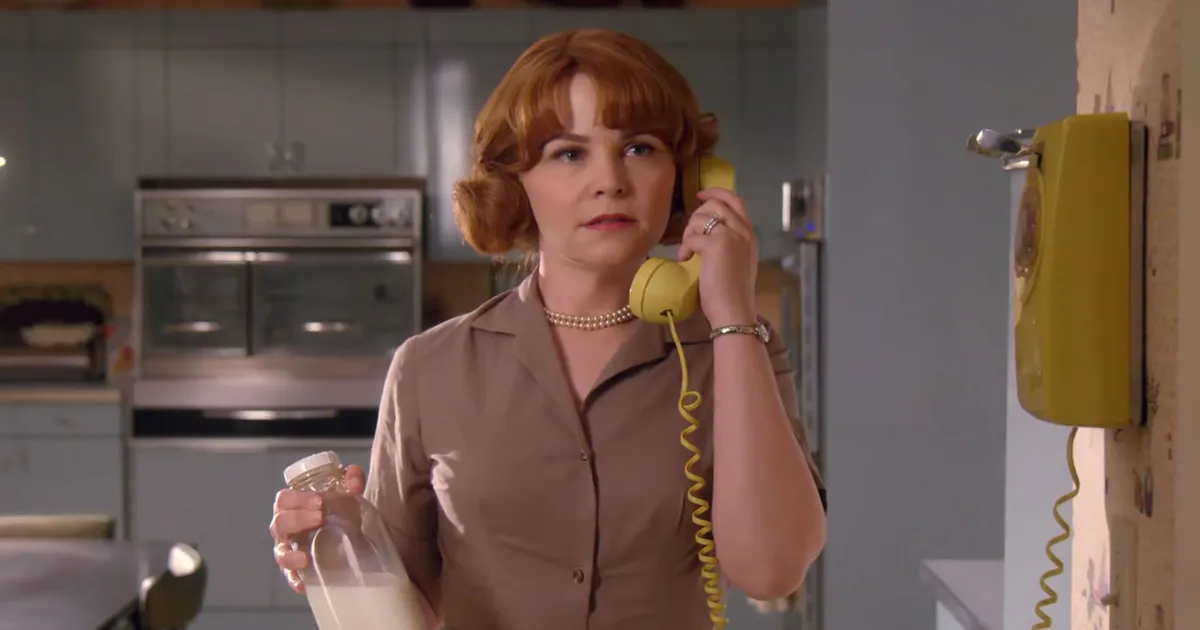Can you describe the style and mood of the setting? The image showcases a retro, mid-century modern kitchen design. The color palette of blue and white evokes a clean and fresh ambiance. The woman's vintage clothing style and the antique phone communicate a sense of nostalgia and a bygone era, creating a mood that's both tranquil and reflective of mid-20th century aesthetics. What might the woman be discussing on the phone? While it's impossible to know the exact topic of her conversation, the woman's expression suggests a casual, perhaps friendly exchange. She could be arranging plans, exchanging pleasantries with a friend, or conducting daily household affairs. 